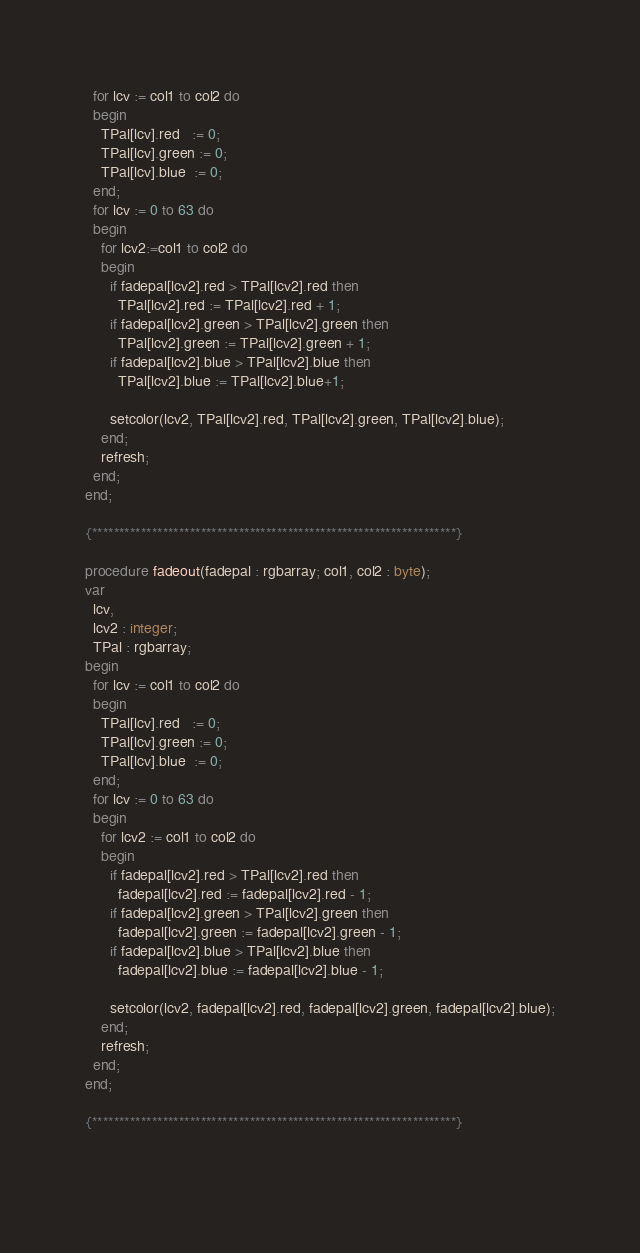Convert code to text. <code><loc_0><loc_0><loc_500><loc_500><_Pascal_>  for lcv := col1 to col2 do
  begin
    TPal[lcv].red   := 0;
    TPal[lcv].green := 0;
    TPal[lcv].blue  := 0;
  end;
  for lcv := 0 to 63 do
  begin
    for lcv2:=col1 to col2 do
    begin
      if fadepal[lcv2].red > TPal[lcv2].red then
        TPal[lcv2].red := TPal[lcv2].red + 1;
      if fadepal[lcv2].green > TPal[lcv2].green then
        TPal[lcv2].green := TPal[lcv2].green + 1;
      if fadepal[lcv2].blue > TPal[lcv2].blue then
        TPal[lcv2].blue := TPal[lcv2].blue+1;

      setcolor(lcv2, TPal[lcv2].red, TPal[lcv2].green, TPal[lcv2].blue);
    end;
    refresh;
  end;
end;

{*******************************************************************}

procedure fadeout(fadepal : rgbarray; col1, col2 : byte);
var
  lcv,
  lcv2 : integer;
  TPal : rgbarray;
begin
  for lcv := col1 to col2 do
  begin
    TPal[lcv].red   := 0;
    TPal[lcv].green := 0;
    TPal[lcv].blue  := 0;
  end;
  for lcv := 0 to 63 do
  begin
    for lcv2 := col1 to col2 do
    begin
      if fadepal[lcv2].red > TPal[lcv2].red then
        fadepal[lcv2].red := fadepal[lcv2].red - 1;
      if fadepal[lcv2].green > TPal[lcv2].green then
        fadepal[lcv2].green := fadepal[lcv2].green - 1;
      if fadepal[lcv2].blue > TPal[lcv2].blue then
        fadepal[lcv2].blue := fadepal[lcv2].blue - 1;

      setcolor(lcv2, fadepal[lcv2].red, fadepal[lcv2].green, fadepal[lcv2].blue);
    end;
    refresh;
  end;
end;

{*******************************************************************}

</code> 